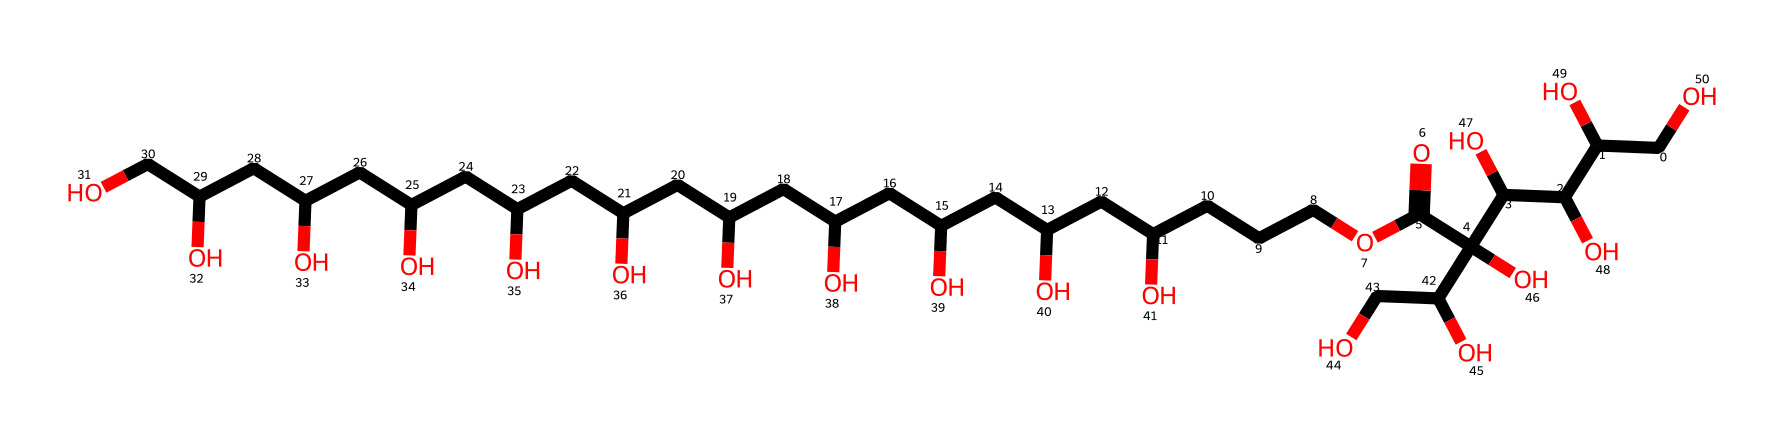What is the molecular formula of this compound? The molecular formula can be derived from counting the number of each type of atom in the SMILES representation. The compound contains Carbon (C), Hydrogen (H), and Oxygen (O) atoms, specifically 20 carbons, 38 hydrogens, and 6 oxygens. Therefore, the molecular formula is C20H38O6.
Answer: C20H38O6 How many hydroxyl groups (–OH) are present in the structure? In the SMILES notation, each instance of 'O' following a 'C' or as part of a 'C(O)' indicates a hydroxyl group. Counting these, there are 6 hydroxyl groups present in the structure, as indicated by the 'O' atoms bonded to various carbon atoms.
Answer: 6 Which part of the molecule contributes to its surfactant properties? Surfactants reduce surface tension and facilitate emulsification. In this structure, the long hydrophobic carbon chain and the hydrophilic hydroxyl groups work together to give it surfactant properties. The hydrophilic parts are derived from the hydroxyl groups, making them attracted to water, while the carbon chains repel water, creating micelles.
Answer: long hydrophobic carbon chain and hydrophilic hydroxyl groups What functional groups are present in polysorbate 20? The SMILES shows multiple –OH (hydroxyl) groups and a carboxylic acid group (indicated by C(=O)O). These are functional groups that characterize polysorbate 20. Identifying these groups helps understand the chemical reactivity and properties of the surfactant.
Answer: hydroxyl and carboxylic acid groups What is the role of polysorbate 20 in personal care items? Polysorbate 20 serves as an emulsifier, helping to mix water and oil-based ingredients. This is critical in personal care formulations for creating stable products like lotions and creams. Its molecular structure allows it to interact with both hydrophobic and hydrophilic substances, which is key to its function.
Answer: emulsifier 